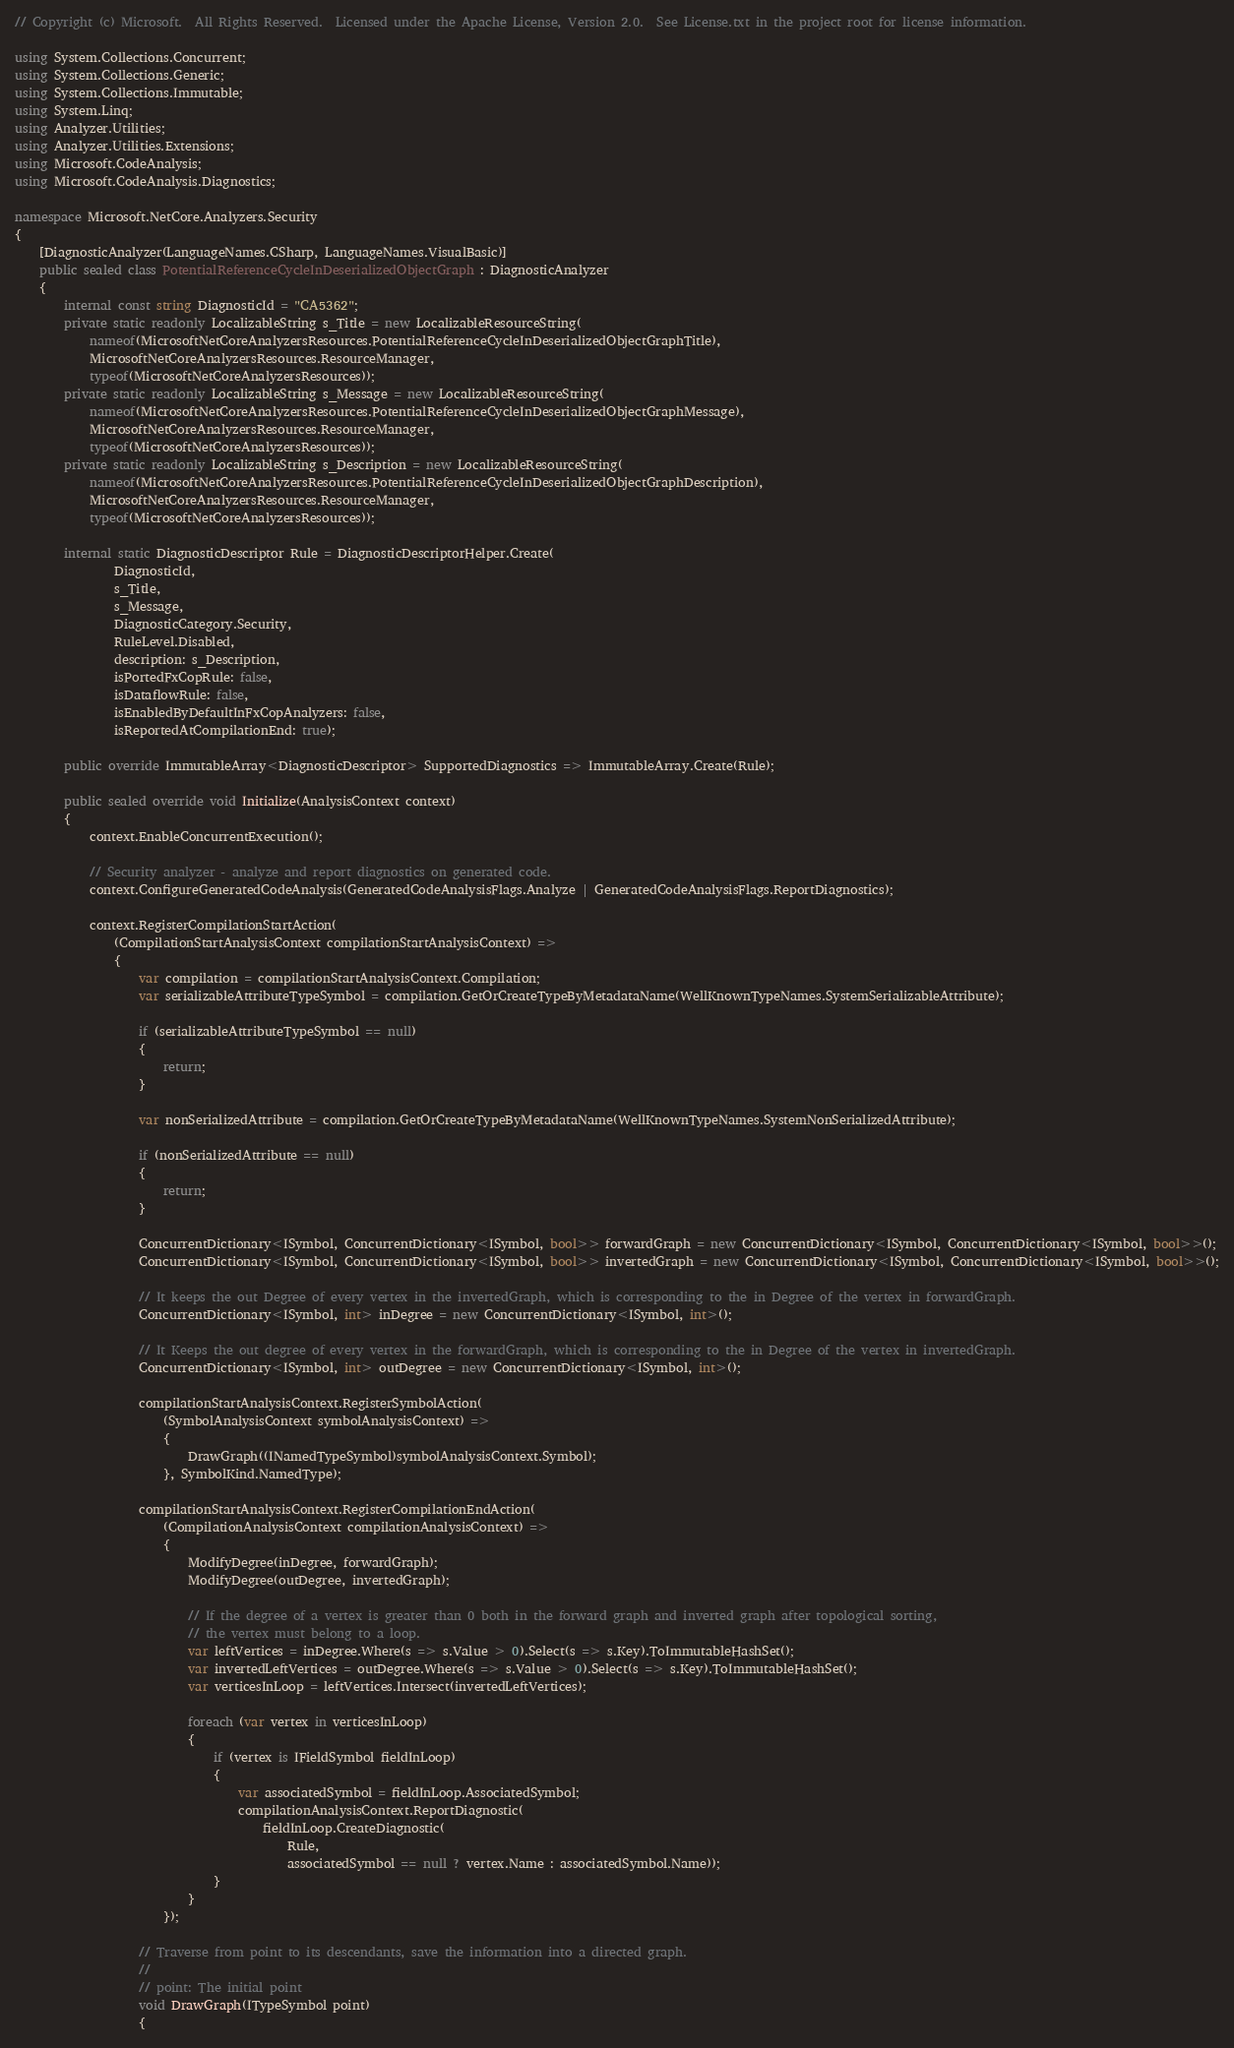Convert code to text. <code><loc_0><loc_0><loc_500><loc_500><_C#_>// Copyright (c) Microsoft.  All Rights Reserved.  Licensed under the Apache License, Version 2.0.  See License.txt in the project root for license information.

using System.Collections.Concurrent;
using System.Collections.Generic;
using System.Collections.Immutable;
using System.Linq;
using Analyzer.Utilities;
using Analyzer.Utilities.Extensions;
using Microsoft.CodeAnalysis;
using Microsoft.CodeAnalysis.Diagnostics;

namespace Microsoft.NetCore.Analyzers.Security
{
    [DiagnosticAnalyzer(LanguageNames.CSharp, LanguageNames.VisualBasic)]
    public sealed class PotentialReferenceCycleInDeserializedObjectGraph : DiagnosticAnalyzer
    {
        internal const string DiagnosticId = "CA5362";
        private static readonly LocalizableString s_Title = new LocalizableResourceString(
            nameof(MicrosoftNetCoreAnalyzersResources.PotentialReferenceCycleInDeserializedObjectGraphTitle),
            MicrosoftNetCoreAnalyzersResources.ResourceManager,
            typeof(MicrosoftNetCoreAnalyzersResources));
        private static readonly LocalizableString s_Message = new LocalizableResourceString(
            nameof(MicrosoftNetCoreAnalyzersResources.PotentialReferenceCycleInDeserializedObjectGraphMessage),
            MicrosoftNetCoreAnalyzersResources.ResourceManager,
            typeof(MicrosoftNetCoreAnalyzersResources));
        private static readonly LocalizableString s_Description = new LocalizableResourceString(
            nameof(MicrosoftNetCoreAnalyzersResources.PotentialReferenceCycleInDeserializedObjectGraphDescription),
            MicrosoftNetCoreAnalyzersResources.ResourceManager,
            typeof(MicrosoftNetCoreAnalyzersResources));

        internal static DiagnosticDescriptor Rule = DiagnosticDescriptorHelper.Create(
                DiagnosticId,
                s_Title,
                s_Message,
                DiagnosticCategory.Security,
                RuleLevel.Disabled,
                description: s_Description,
                isPortedFxCopRule: false,
                isDataflowRule: false,
                isEnabledByDefaultInFxCopAnalyzers: false,
                isReportedAtCompilationEnd: true);

        public override ImmutableArray<DiagnosticDescriptor> SupportedDiagnostics => ImmutableArray.Create(Rule);

        public sealed override void Initialize(AnalysisContext context)
        {
            context.EnableConcurrentExecution();

            // Security analyzer - analyze and report diagnostics on generated code.
            context.ConfigureGeneratedCodeAnalysis(GeneratedCodeAnalysisFlags.Analyze | GeneratedCodeAnalysisFlags.ReportDiagnostics);

            context.RegisterCompilationStartAction(
                (CompilationStartAnalysisContext compilationStartAnalysisContext) =>
                {
                    var compilation = compilationStartAnalysisContext.Compilation;
                    var serializableAttributeTypeSymbol = compilation.GetOrCreateTypeByMetadataName(WellKnownTypeNames.SystemSerializableAttribute);

                    if (serializableAttributeTypeSymbol == null)
                    {
                        return;
                    }

                    var nonSerializedAttribute = compilation.GetOrCreateTypeByMetadataName(WellKnownTypeNames.SystemNonSerializedAttribute);

                    if (nonSerializedAttribute == null)
                    {
                        return;
                    }

                    ConcurrentDictionary<ISymbol, ConcurrentDictionary<ISymbol, bool>> forwardGraph = new ConcurrentDictionary<ISymbol, ConcurrentDictionary<ISymbol, bool>>();
                    ConcurrentDictionary<ISymbol, ConcurrentDictionary<ISymbol, bool>> invertedGraph = new ConcurrentDictionary<ISymbol, ConcurrentDictionary<ISymbol, bool>>();

                    // It keeps the out Degree of every vertex in the invertedGraph, which is corresponding to the in Degree of the vertex in forwardGraph.
                    ConcurrentDictionary<ISymbol, int> inDegree = new ConcurrentDictionary<ISymbol, int>();

                    // It Keeps the out degree of every vertex in the forwardGraph, which is corresponding to the in Degree of the vertex in invertedGraph.
                    ConcurrentDictionary<ISymbol, int> outDegree = new ConcurrentDictionary<ISymbol, int>();

                    compilationStartAnalysisContext.RegisterSymbolAction(
                        (SymbolAnalysisContext symbolAnalysisContext) =>
                        {
                            DrawGraph((INamedTypeSymbol)symbolAnalysisContext.Symbol);
                        }, SymbolKind.NamedType);

                    compilationStartAnalysisContext.RegisterCompilationEndAction(
                        (CompilationAnalysisContext compilationAnalysisContext) =>
                        {
                            ModifyDegree(inDegree, forwardGraph);
                            ModifyDegree(outDegree, invertedGraph);

                            // If the degree of a vertex is greater than 0 both in the forward graph and inverted graph after topological sorting,
                            // the vertex must belong to a loop.
                            var leftVertices = inDegree.Where(s => s.Value > 0).Select(s => s.Key).ToImmutableHashSet();
                            var invertedLeftVertices = outDegree.Where(s => s.Value > 0).Select(s => s.Key).ToImmutableHashSet();
                            var verticesInLoop = leftVertices.Intersect(invertedLeftVertices);

                            foreach (var vertex in verticesInLoop)
                            {
                                if (vertex is IFieldSymbol fieldInLoop)
                                {
                                    var associatedSymbol = fieldInLoop.AssociatedSymbol;
                                    compilationAnalysisContext.ReportDiagnostic(
                                        fieldInLoop.CreateDiagnostic(
                                            Rule,
                                            associatedSymbol == null ? vertex.Name : associatedSymbol.Name));
                                }
                            }
                        });

                    // Traverse from point to its descendants, save the information into a directed graph.
                    //
                    // point: The initial point
                    void DrawGraph(ITypeSymbol point)
                    {</code> 